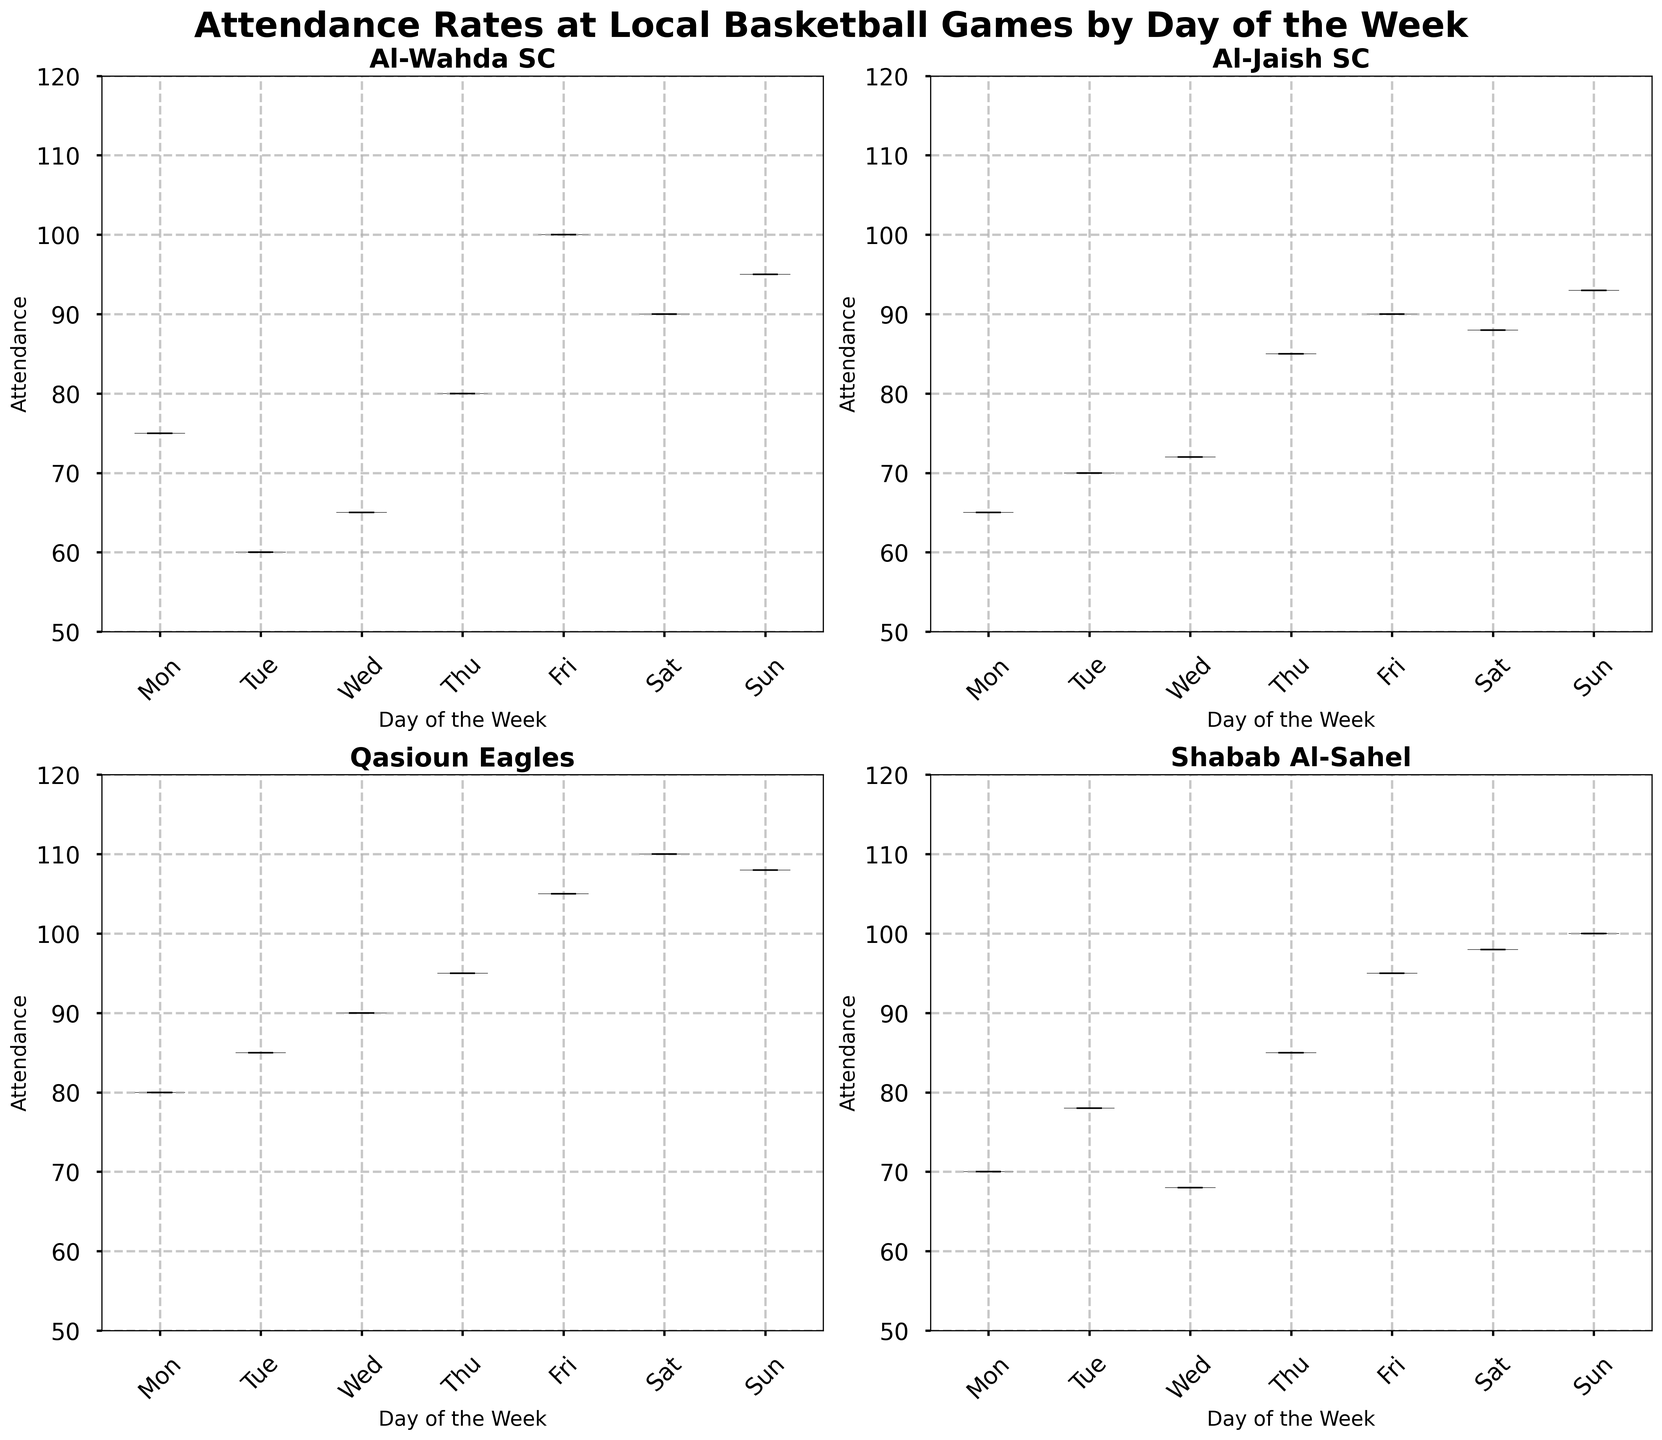What is the title of the figure? The title is written at the top of the figure in large, bold text.
Answer: Attendance Rates at Local Basketball Games by Day of the Week Which team appears in the first subplot (top left)? The subplots are arranged in a 2x2 grid, and the first subplot is located at the top left. The title above this subplot indicates the team name.
Answer: Al-Wahda SC How many unique days are represented on the x-axis of each subplot? The x-axis of each subplot is labeled with ticks representing the days of the week, which are Monday to Sunday. Counting these ticks gives the total number of unique days represented.
Answer: 7 Which day has the highest median attendance for Qasioun Eagles? In the subplot for Qasioun Eagles, the median is represented by a horizontal line inside each violin. The tallest median line corresponds to the highest median attendance.
Answer: Saturday Compare the attendance rates on Friday and Sunday for Shabab Al-Sahel. Which day shows higher attendance? In the subplot for Shabab Al-Sahel, observe the violins for Friday and Sunday. The one with a higher range indicates higher attendance.
Answer: Sunday What is the mean attendance on Thursday for Al-Jaish SC? In the Al-Jaish SC subplot, the mean is represented by a point inside the Thursday violin.
Answer: 85 For Al-Wahda SC, what is the range of attendance values on Saturday (from minimum to maximum)? In the Al-Wahda SC subplot, the minimum and maximum values are represented by the lower and upper whiskers of the Saturday violin plot, respectively.
Answer: 90 to 90 What trend can be observed in the attendance rates for Al-Jaish SC from Monday to Sunday? In the Al-Jaish SC subplot, observe the change in the position and shape of the violins from Monday to Sunday to identify any increasing or decreasing trends.
Answer: Steady increase Which team has the highest variability in attendance, and how can you tell? By observing the spread and width of the violins in each subplot, the team with the widest violins demonstrates the highest variability.
Answer: Qasioun Eagles How does the attendance on Wednesday for Qasioun Eagles compare with Al-Wahda SC? Compare the two Wednesday violins from the respective subplots of Qasioun Eagles and Al-Wahda SC. The violin with a higher position indicates higher attendance.
Answer: Higher for Qasioun Eagles 